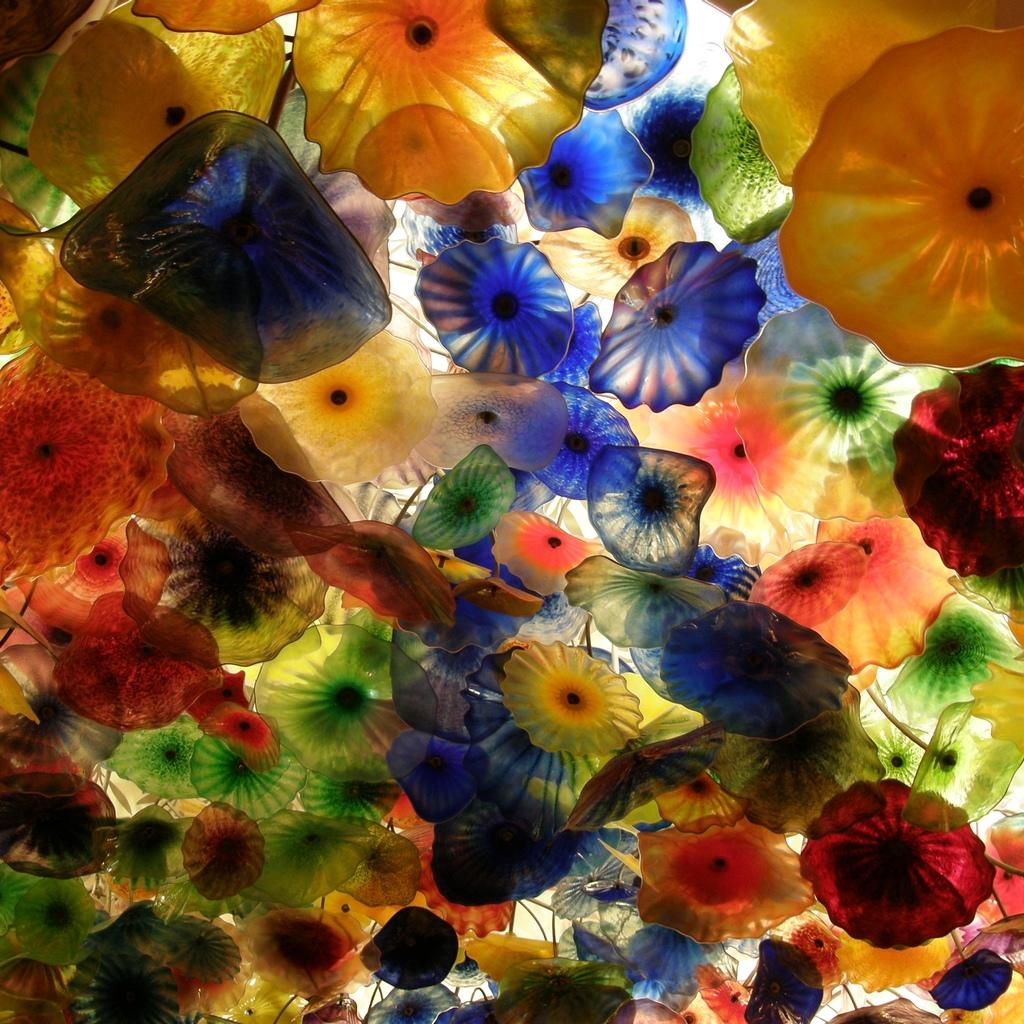What is the main subject of the image? The main subject of the image is a glass art. What can be observed about the glass art in the image? There are different colors of flowers present in the image. Reasoning: Let's think step by breaking down the conversation step by step. First, we identify the main subject of the image, which is a glass art. Then, we describe the specific details about the glass art, focusing on the colors and types of flowers depicted. We ensure that each question can be answered definitively with the information given and avoid yes/no questions. Absurd Question/Answer: What nation is responsible for creating the glass art in the image? The provided facts do not mention the origin or nation responsible for creating the glass art, so it cannot be determined from the image. What trick is being performed by the flowers in the glass art? There is no trick being performed by the flowers in the image; they are simply depicted as part of the glass art. 